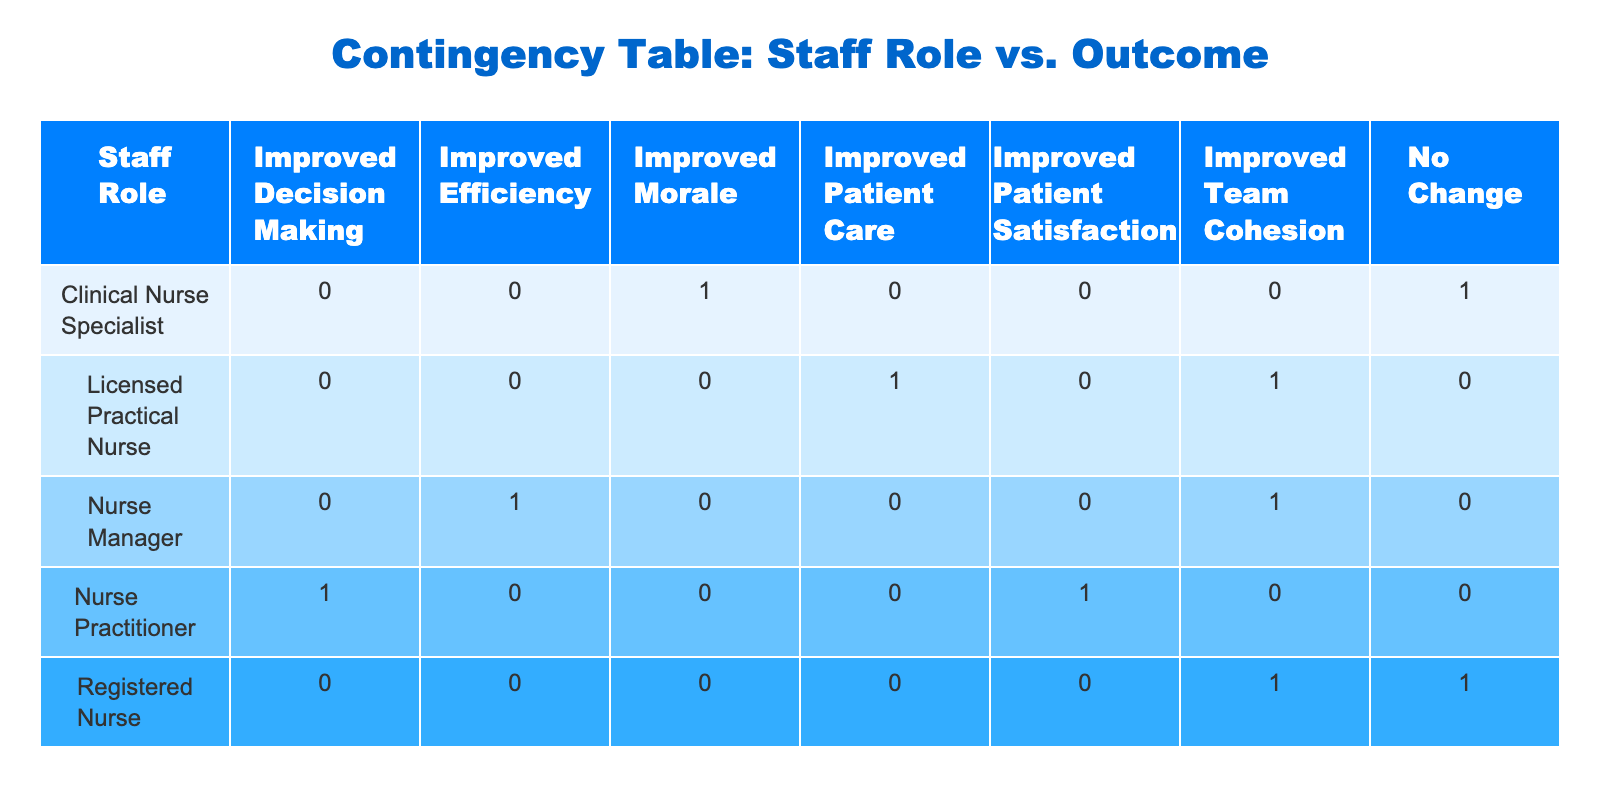What training session did the Licensed Practical Nurses attend that resulted in improved patient care? According to the table, the Licensed Practical Nurse attended the "Leadership Skills Workshop," which specifically mentions the outcome as "Improved Patient Care."
Answer: Leadership Skills Workshop How many training sessions did Nurse Managers attend in total? The table lists two training sessions attended by Nurse Managers: "Leadership Skills Workshop" and "Time Management Seminar." Therefore, adding them gives 2 sessions in total.
Answer: 2 Does the table show that any training session resulted in a "No Change" outcome for Registered Nurses? By checking the outcomes for Registered Nurses, the only session listed is the "Time Management Seminar," which indeed resulted in "No Change." Thus, the answer is yes.
Answer: Yes What is the total number of sessions that led to "Improved Team Cohesion"? From the table, the training sessions resulting in "Improved Team Cohesion" are: "Leadership Skills Workshop" for both Registered Nurses and Nurse Managers and "Conflict Resolution Training" for Licensed Practical Nurses. Thus, 3 sessions in total lead to this outcome.
Answer: 3 Which staff role had the highest number of different outcomes from the training sessions attended? The Nurse Practitioner attended 2 different sessions—one leading to "Improved Decision Making" and the other to "Improved Patient Satisfaction." On the other hand, other roles had fewer varied outcomes when counted. Therefore, the Nurse Practitioner stands out in this aspect.
Answer: Nurse Practitioner How many outcomes were listed for the Clinical Nurse Specialist, and what were they? The table shows Clinical Nurse Specialist attended two sessions with outcomes: "Improved Morale" from "Team Building Strategies" and "No Change" from "Conflict Resolution Training." This makes 2 unique outcomes.
Answer: 2 outcomes: Improved Morale, No Change Are there any training sessions that led to improved efficiency? The table indicates that the "Time Management Seminar" resulted in "Improved Efficiency" when attended by Nurse Managers. Therefore, it is confirmed that at least this session led to such an outcome.
Answer: Yes Which outcome appears most frequently among all staff roles? By analyzing the table, "Improved Team Cohesion" appears 3 times in different contexts (from sessions attended by Nurse Managers and Licensed Practical Nurses), which is more frequent compared to all other outcomes. Therefore, this outcome is the most common.
Answer: Improved Team Cohesion 